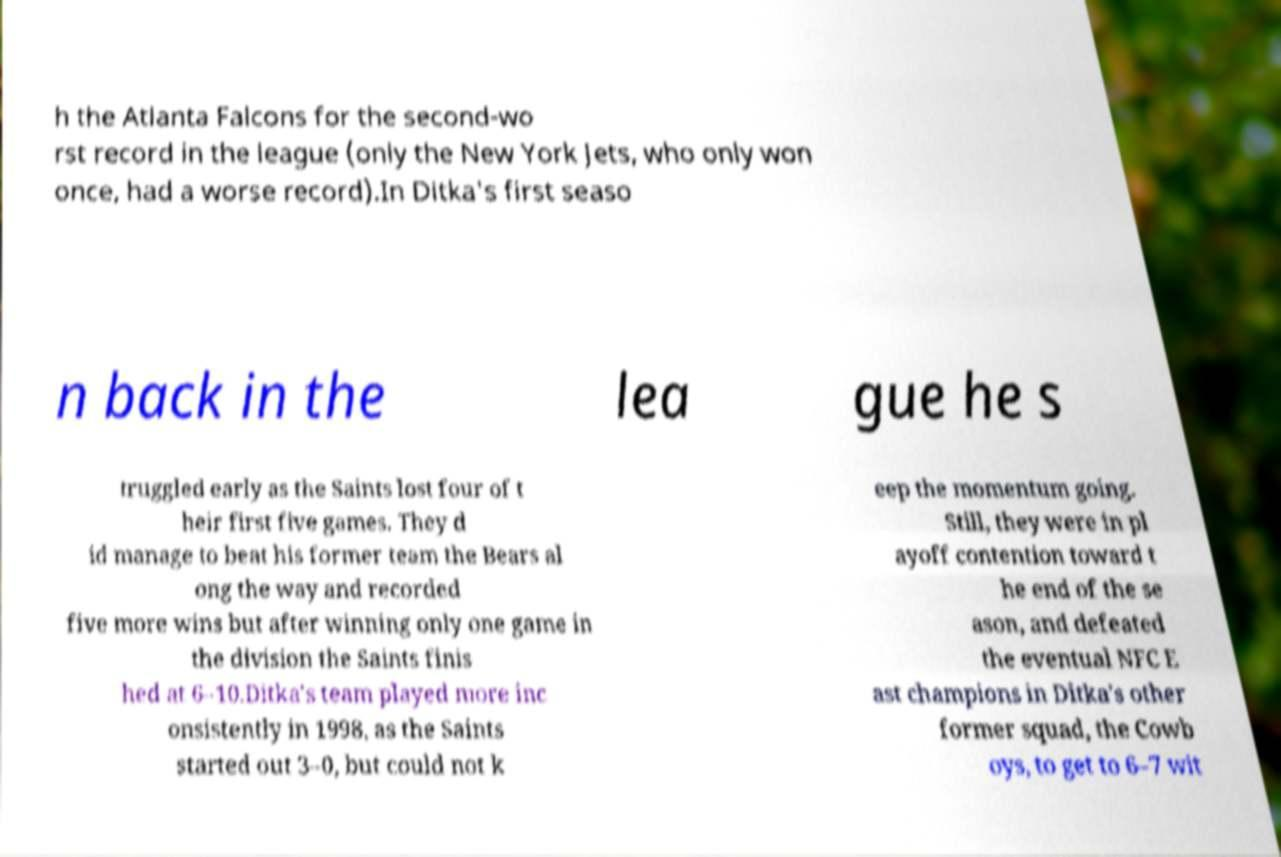Please identify and transcribe the text found in this image. h the Atlanta Falcons for the second-wo rst record in the league (only the New York Jets, who only won once, had a worse record).In Ditka's first seaso n back in the lea gue he s truggled early as the Saints lost four of t heir first five games. They d id manage to beat his former team the Bears al ong the way and recorded five more wins but after winning only one game in the division the Saints finis hed at 6–10.Ditka's team played more inc onsistently in 1998, as the Saints started out 3–0, but could not k eep the momentum going. Still, they were in pl ayoff contention toward t he end of the se ason, and defeated the eventual NFC E ast champions in Ditka's other former squad, the Cowb oys, to get to 6–7 wit 